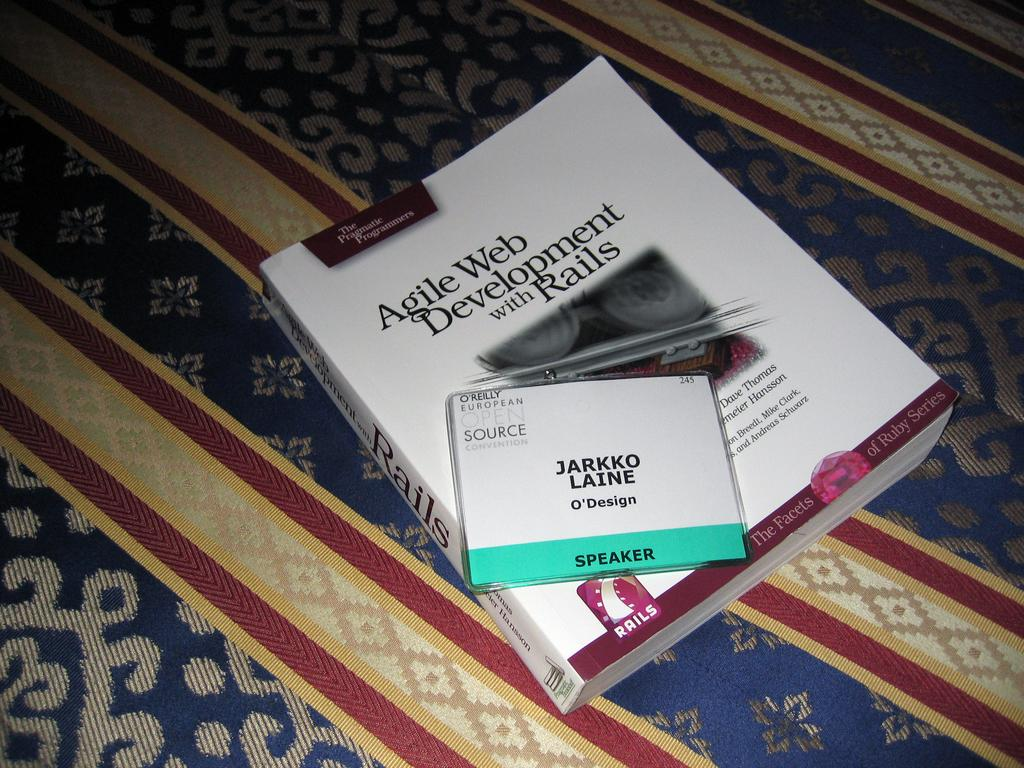<image>
Share a concise interpretation of the image provided. The book Agile Web Development with Rails is laying on a rug with a speaker's convention laminate badge on top of it. 